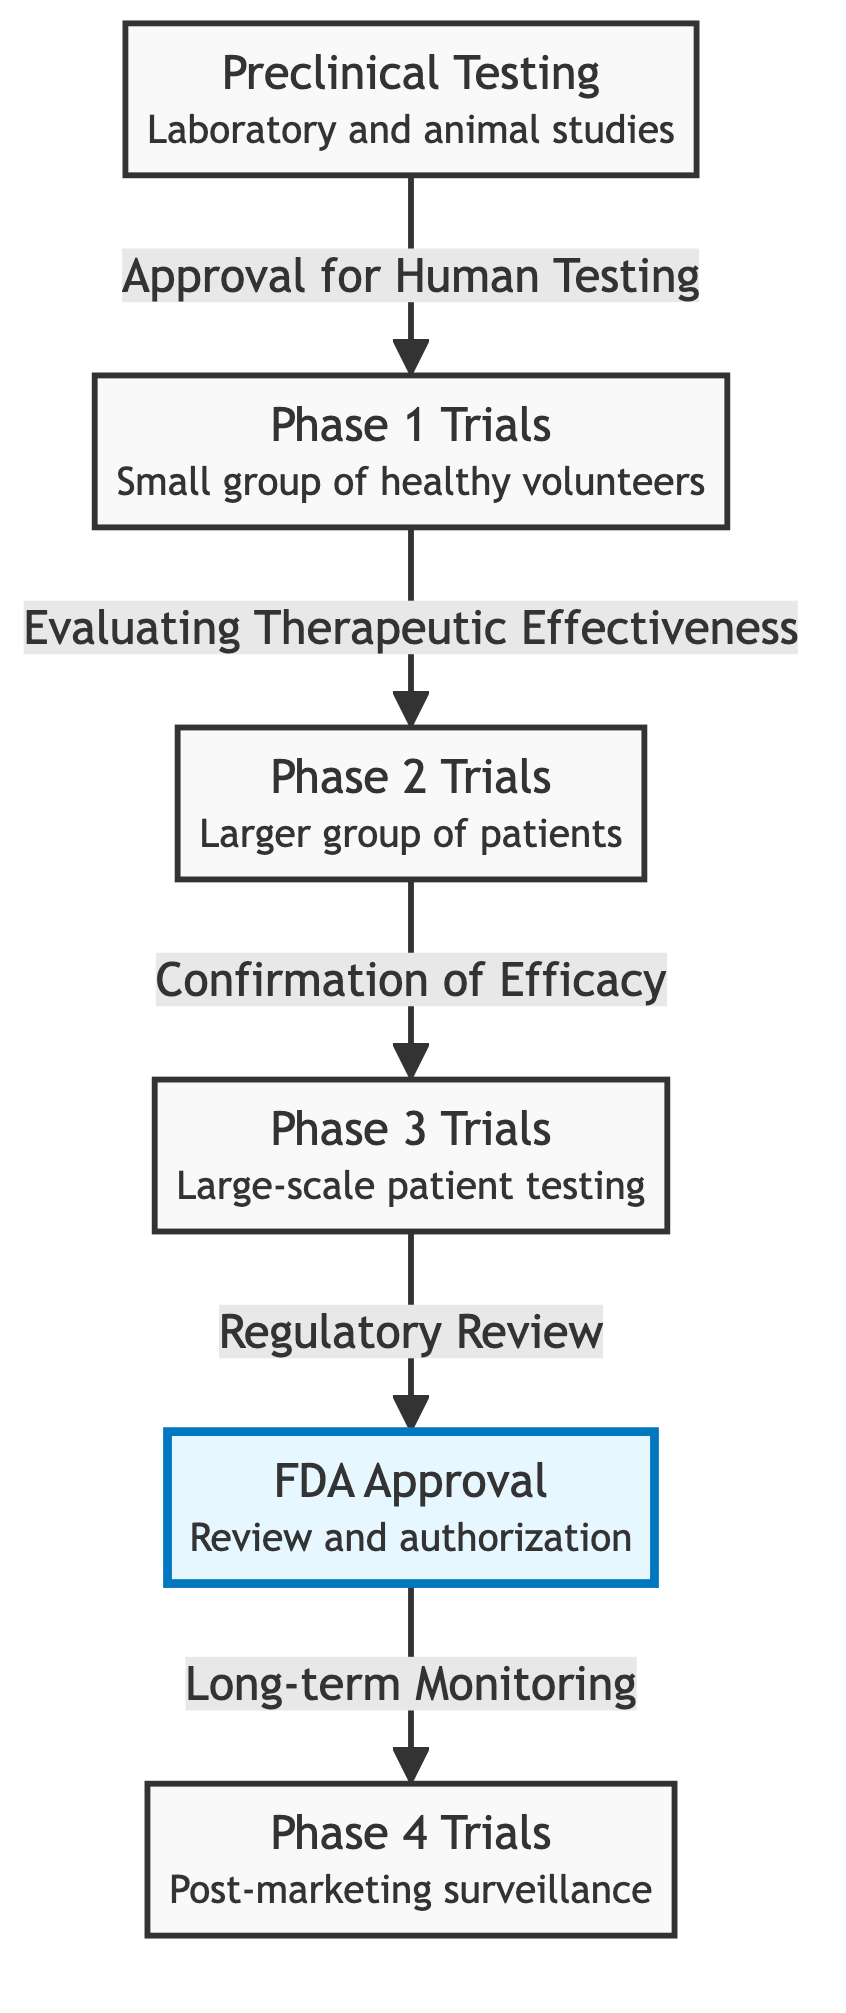What is the first stage in clinical trials? The diagram shows that the first stage in clinical trials is Preclinical Testing, as it is the starting point of the flowchart.
Answer: Preclinical Testing How many phases are there in clinical trials? The diagram presents a total of five main stages: Preclinical Testing, Phase 1 Trials, Phase 2 Trials, Phase 3 Trials, and Phase 4 Trials.
Answer: Five Which trial phase involves a large-scale patient testing? According to the diagram, Phase 3 Trials involve large-scale patient testing, indicated by its description in the flowchart.
Answer: Phase 3 Trials What is the purpose of FDA Approval in the diagram? The diagram indicates that FDA Approval serves the purpose of review and authorization, as specified in the label of that node.
Answer: Review and authorization What follows Phase 3 Trials in the flowchart? After analyzing the flowchart, it is clear that FDA Approval follows Phase 3 Trials, establishing a transition to the next stage.
Answer: FDA Approval What is conducted after FDA Approval? The flowchart indicates that Phase 4 Trials, which focus on post-marketing surveillance, are conducted after FDA Approval, as shown by the directed arrow.
Answer: Phase 4 Trials Which phase evaluates therapeutic effectiveness? The diagram clarifies that Phase 1 Trials evaluate therapeutic effectiveness, as indicated by the label on that specific node.
Answer: Phase 1 Trials In total, how many edges connect the stages of clinical trials? By counting the connections in the diagram, there are four directed edges connecting the five stages, demonstrating the flow between them.
Answer: Four 